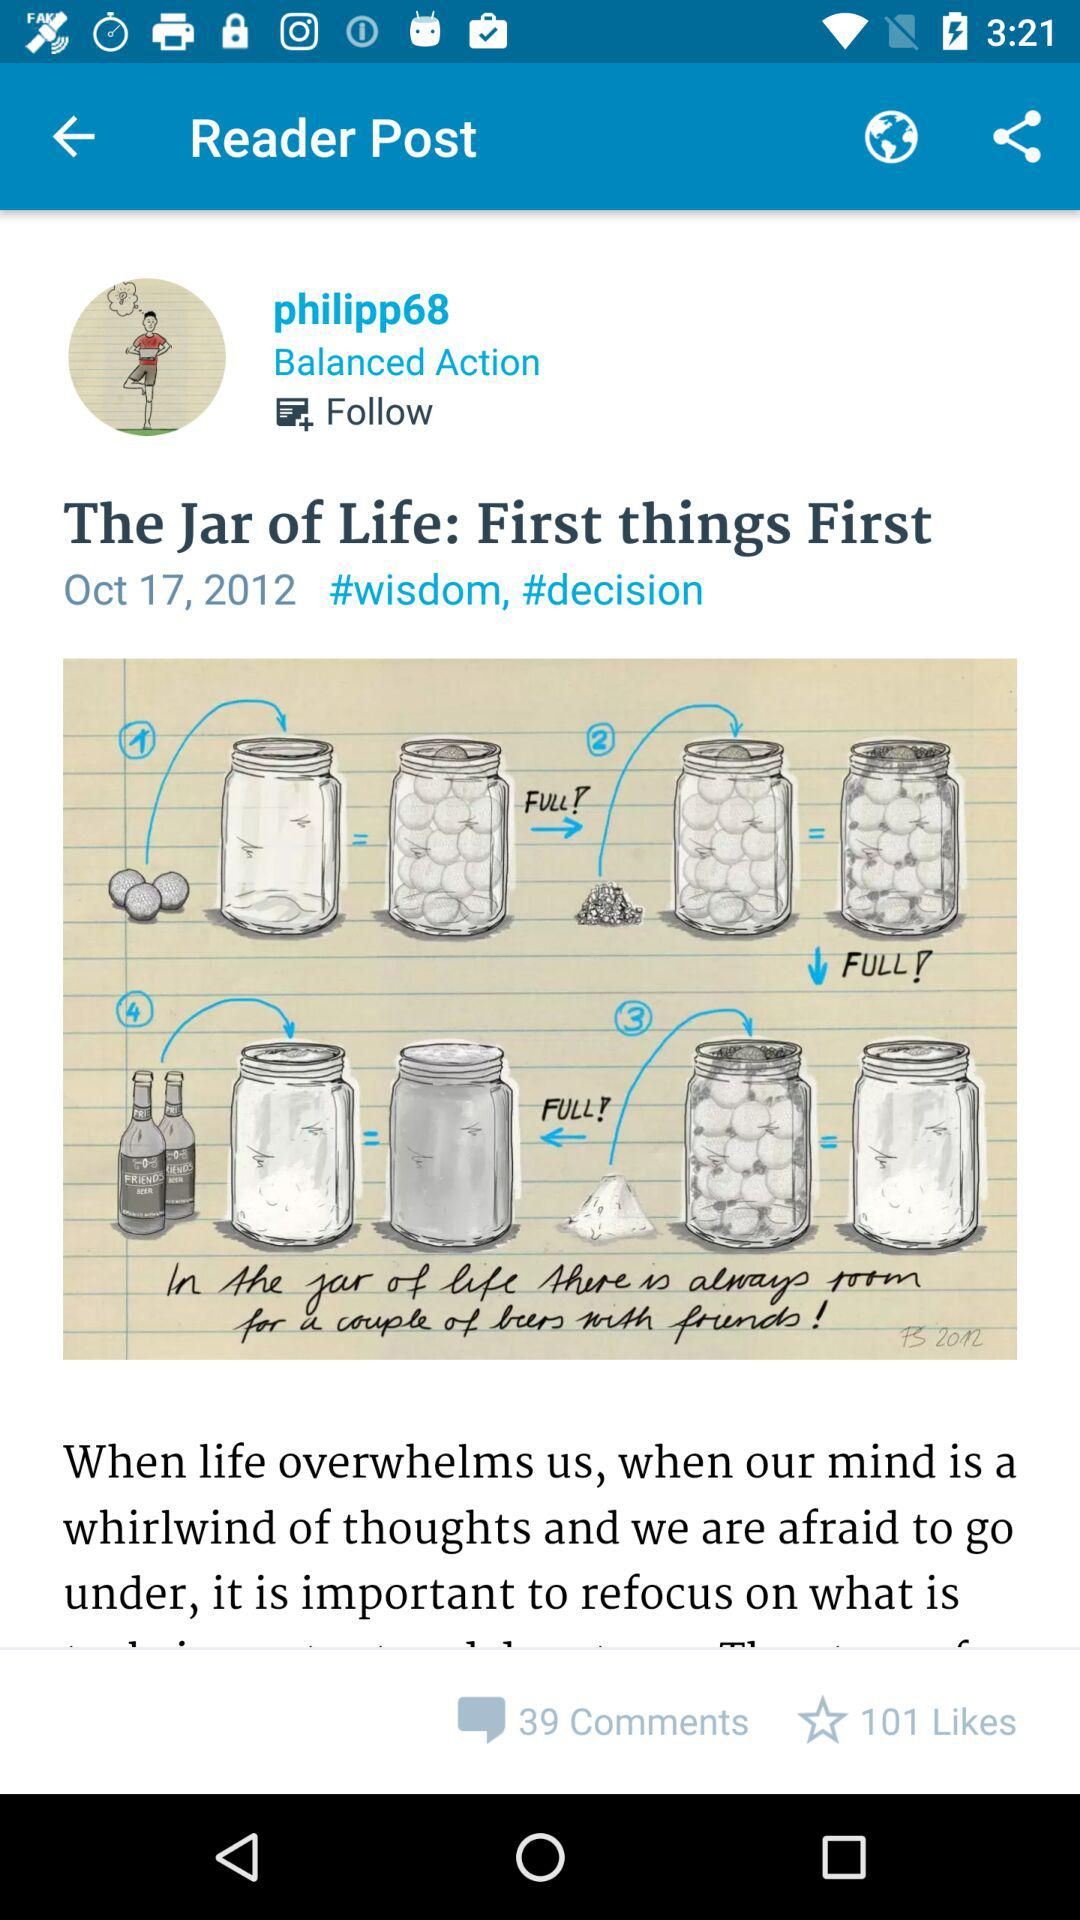How many more likes than comments does the post have?
Answer the question using a single word or phrase. 62 